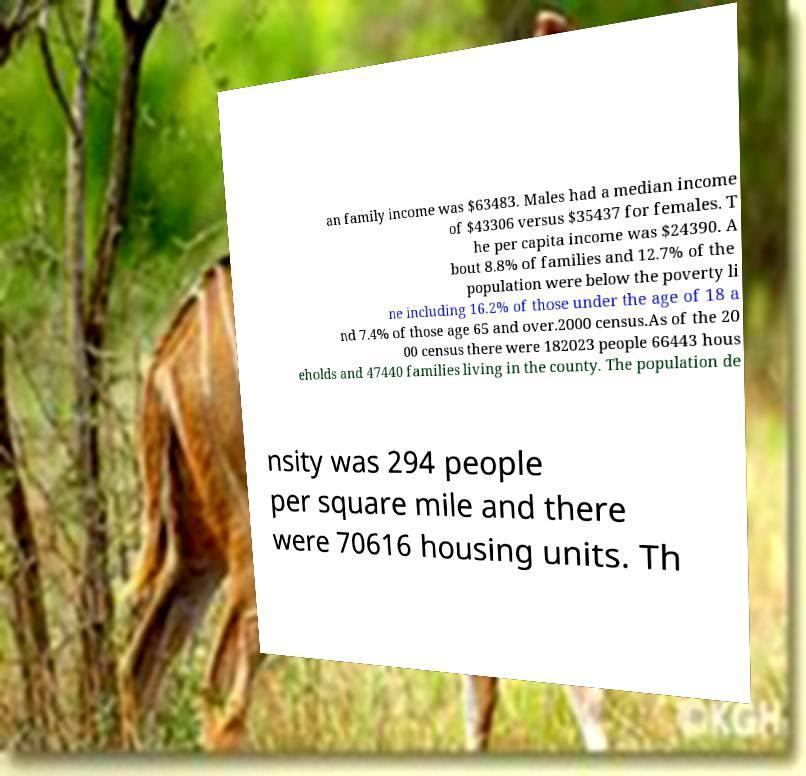What messages or text are displayed in this image? I need them in a readable, typed format. an family income was $63483. Males had a median income of $43306 versus $35437 for females. T he per capita income was $24390. A bout 8.8% of families and 12.7% of the population were below the poverty li ne including 16.2% of those under the age of 18 a nd 7.4% of those age 65 and over.2000 census.As of the 20 00 census there were 182023 people 66443 hous eholds and 47440 families living in the county. The population de nsity was 294 people per square mile and there were 70616 housing units. Th 